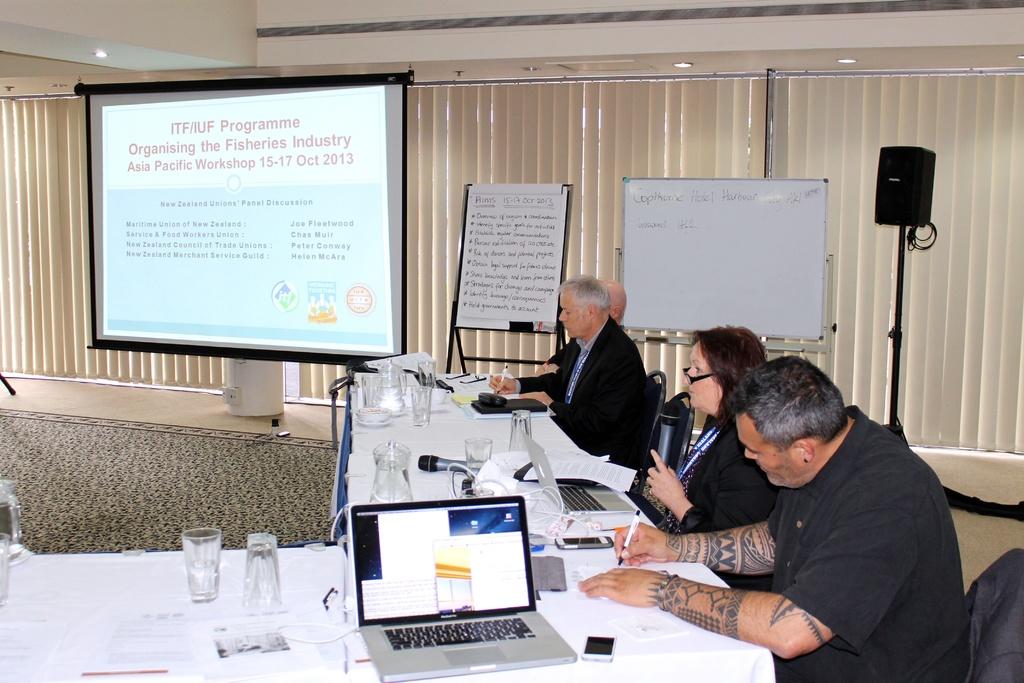What is the date of the workshop?
Offer a very short reply. 15-17 oct 2013. 